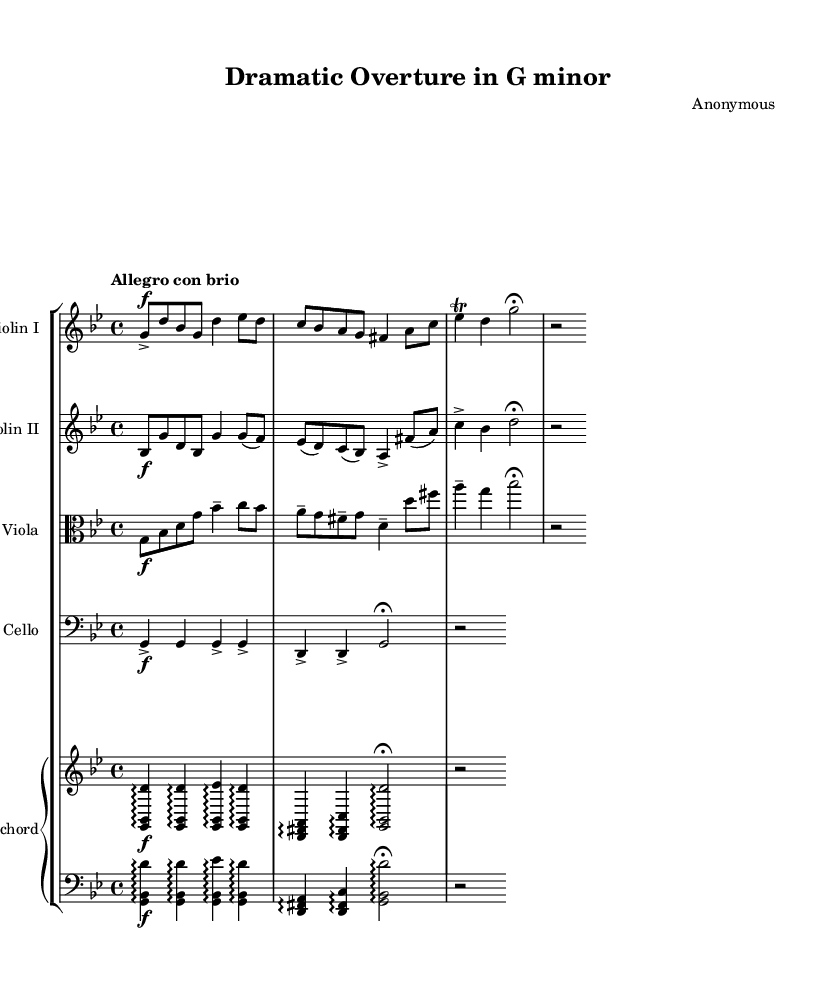What is the key signature of this music? The key signature is G minor, which has two flats (B♭ and E♭). This can be identified by looking at the key signature placed at the beginning of the staff.
Answer: G minor What is the time signature of this music? The time signature is 4/4, which is shown at the beginning of the sheet music. This indicates that there are four beats in each measure and a quarter note receives one beat.
Answer: 4/4 What is the tempo marking of this piece? The tempo marking is "Allegro con brio," indicating a fast, lively pace. This can be found in the tempo instruction at the beginning of the score.
Answer: Allegro con brio How many instruments are scored in this ensemble? There are five distinct instruments scored in this ensemble: Violin I, Violin II, Viola, Cello, and Harpsichord. This can be deduced from the instrument labels at the beginning of each staff.
Answer: Five Which section features a trill? The section featuring a trill is played by Violin I, specifically on the note D. The trill is indicated by the notation that shows a squiggly line above the note indicating ornamentation.
Answer: Violin I What type of harmony is predominantly used in this piece? The harmony is predominantly built with arpeggios, evident in the harpsichord part that features broken chords. This characteristic is typical of the Baroque era, where such textural elements are common.
Answer: Arpeggios What is the overall mood conveyed by the music? The overall mood conveyed by the music is dramatic, illustrated by the dynamic markings (forte) and the lively tempo, contributing to a sense of urgency and emotional intensity.
Answer: Dramatic 